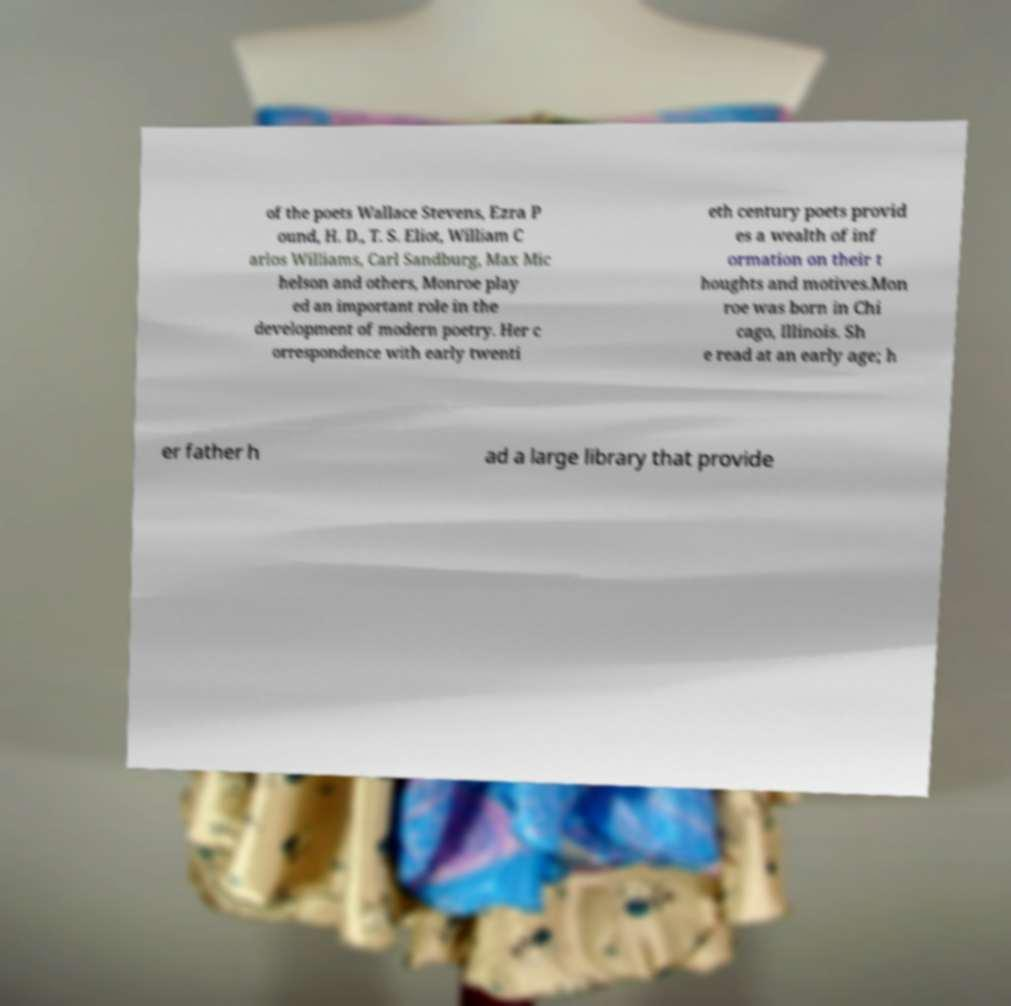I need the written content from this picture converted into text. Can you do that? of the poets Wallace Stevens, Ezra P ound, H. D., T. S. Eliot, William C arlos Williams, Carl Sandburg, Max Mic helson and others, Monroe play ed an important role in the development of modern poetry. Her c orrespondence with early twenti eth century poets provid es a wealth of inf ormation on their t houghts and motives.Mon roe was born in Chi cago, Illinois. Sh e read at an early age; h er father h ad a large library that provide 